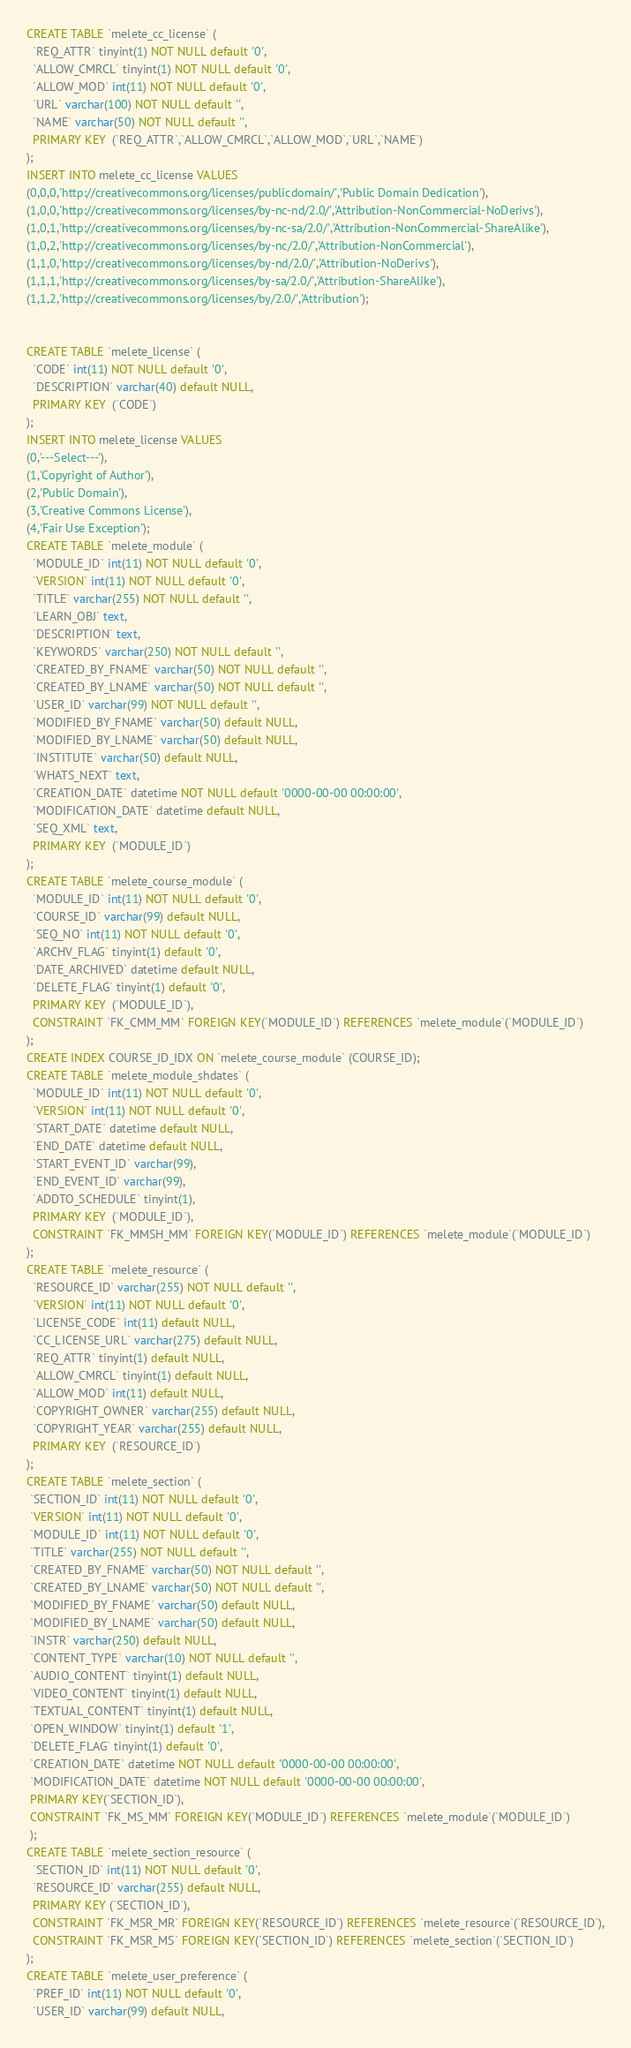Convert code to text. <code><loc_0><loc_0><loc_500><loc_500><_SQL_>CREATE TABLE `melete_cc_license` (
  `REQ_ATTR` tinyint(1) NOT NULL default '0',
  `ALLOW_CMRCL` tinyint(1) NOT NULL default '0',
  `ALLOW_MOD` int(11) NOT NULL default '0',
  `URL` varchar(100) NOT NULL default '',
  `NAME` varchar(50) NOT NULL default '',
  PRIMARY KEY  (`REQ_ATTR`,`ALLOW_CMRCL`,`ALLOW_MOD`,`URL`,`NAME`)
);
INSERT INTO melete_cc_license VALUES 
(0,0,0,'http://creativecommons.org/licenses/publicdomain/','Public Domain Dedication'),
(1,0,0,'http://creativecommons.org/licenses/by-nc-nd/2.0/','Attribution-NonCommercial-NoDerivs'),
(1,0,1,'http://creativecommons.org/licenses/by-nc-sa/2.0/','Attribution-NonCommercial-ShareAlike'),
(1,0,2,'http://creativecommons.org/licenses/by-nc/2.0/','Attribution-NonCommercial'),
(1,1,0,'http://creativecommons.org/licenses/by-nd/2.0/','Attribution-NoDerivs'),
(1,1,1,'http://creativecommons.org/licenses/by-sa/2.0/','Attribution-ShareAlike'),
(1,1,2,'http://creativecommons.org/licenses/by/2.0/','Attribution');


CREATE TABLE `melete_license` (
  `CODE` int(11) NOT NULL default '0',
  `DESCRIPTION` varchar(40) default NULL,
  PRIMARY KEY  (`CODE`)
);
INSERT INTO melete_license VALUES 
(0,'---Select---'),
(1,'Copyright of Author'),
(2,'Public Domain'),
(3,'Creative Commons License'),
(4,'Fair Use Exception');
CREATE TABLE `melete_module` (
  `MODULE_ID` int(11) NOT NULL default '0',
  `VERSION` int(11) NOT NULL default '0',
  `TITLE` varchar(255) NOT NULL default '',
  `LEARN_OBJ` text,
  `DESCRIPTION` text,
  `KEYWORDS` varchar(250) NOT NULL default '',
  `CREATED_BY_FNAME` varchar(50) NOT NULL default '',
  `CREATED_BY_LNAME` varchar(50) NOT NULL default '',
  `USER_ID` varchar(99) NOT NULL default '',
  `MODIFIED_BY_FNAME` varchar(50) default NULL,
  `MODIFIED_BY_LNAME` varchar(50) default NULL,
  `INSTITUTE` varchar(50) default NULL,
  `WHATS_NEXT` text,
  `CREATION_DATE` datetime NOT NULL default '0000-00-00 00:00:00',
  `MODIFICATION_DATE` datetime default NULL,
  `SEQ_XML` text,
  PRIMARY KEY  (`MODULE_ID`)
);
CREATE TABLE `melete_course_module` (
  `MODULE_ID` int(11) NOT NULL default '0',
  `COURSE_ID` varchar(99) default NULL,
  `SEQ_NO` int(11) NOT NULL default '0',
  `ARCHV_FLAG` tinyint(1) default '0',
  `DATE_ARCHIVED` datetime default NULL,
  `DELETE_FLAG` tinyint(1) default '0',
  PRIMARY KEY  (`MODULE_ID`),
  CONSTRAINT `FK_CMM_MM` FOREIGN KEY(`MODULE_ID`) REFERENCES `melete_module`(`MODULE_ID`)
);
CREATE INDEX COURSE_ID_IDX ON `melete_course_module` (COURSE_ID); 
CREATE TABLE `melete_module_shdates` (
  `MODULE_ID` int(11) NOT NULL default '0',
  `VERSION` int(11) NOT NULL default '0',
  `START_DATE` datetime default NULL,
  `END_DATE` datetime default NULL,
  `START_EVENT_ID` varchar(99),
  `END_EVENT_ID` varchar(99),
  `ADDTO_SCHEDULE` tinyint(1),
  PRIMARY KEY  (`MODULE_ID`),
  CONSTRAINT `FK_MMSH_MM` FOREIGN KEY(`MODULE_ID`) REFERENCES `melete_module`(`MODULE_ID`)
);
CREATE TABLE `melete_resource` (
  `RESOURCE_ID` varchar(255) NOT NULL default '',
  `VERSION` int(11) NOT NULL default '0',
  `LICENSE_CODE` int(11) default NULL,
  `CC_LICENSE_URL` varchar(275) default NULL,
  `REQ_ATTR` tinyint(1) default NULL,
  `ALLOW_CMRCL` tinyint(1) default NULL,
  `ALLOW_MOD` int(11) default NULL,
  `COPYRIGHT_OWNER` varchar(255) default NULL,
  `COPYRIGHT_YEAR` varchar(255) default NULL,
  PRIMARY KEY  (`RESOURCE_ID`)
);
CREATE TABLE `melete_section` (
 `SECTION_ID` int(11) NOT NULL default '0',
 `VERSION` int(11) NOT NULL default '0',
 `MODULE_ID` int(11) NOT NULL default '0',
 `TITLE` varchar(255) NOT NULL default '',
 `CREATED_BY_FNAME` varchar(50) NOT NULL default '',
 `CREATED_BY_LNAME` varchar(50) NOT NULL default '',
 `MODIFIED_BY_FNAME` varchar(50) default NULL,
 `MODIFIED_BY_LNAME` varchar(50) default NULL,
 `INSTR` varchar(250) default NULL,
 `CONTENT_TYPE` varchar(10) NOT NULL default '',
 `AUDIO_CONTENT` tinyint(1) default NULL,
 `VIDEO_CONTENT` tinyint(1) default NULL,
 `TEXTUAL_CONTENT` tinyint(1) default NULL,
 `OPEN_WINDOW` tinyint(1) default '1',
 `DELETE_FLAG` tinyint(1) default '0',
 `CREATION_DATE` datetime NOT NULL default '0000-00-00 00:00:00',
 `MODIFICATION_DATE` datetime NOT NULL default '0000-00-00 00:00:00',
 PRIMARY KEY(`SECTION_ID`),
 CONSTRAINT `FK_MS_MM` FOREIGN KEY(`MODULE_ID`) REFERENCES `melete_module`(`MODULE_ID`)
 );
CREATE TABLE `melete_section_resource` (
  `SECTION_ID` int(11) NOT NULL default '0',
  `RESOURCE_ID` varchar(255) default NULL,
  PRIMARY KEY (`SECTION_ID`),
  CONSTRAINT `FK_MSR_MR` FOREIGN KEY(`RESOURCE_ID`) REFERENCES `melete_resource`(`RESOURCE_ID`),
  CONSTRAINT `FK_MSR_MS` FOREIGN KEY(`SECTION_ID`) REFERENCES `melete_section`(`SECTION_ID`)
);
CREATE TABLE `melete_user_preference` (
  `PREF_ID` int(11) NOT NULL default '0',
  `USER_ID` varchar(99) default NULL,</code> 